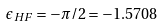<formula> <loc_0><loc_0><loc_500><loc_500>\epsilon _ { H F } = - \pi / 2 = - 1 . 5 7 0 8</formula> 